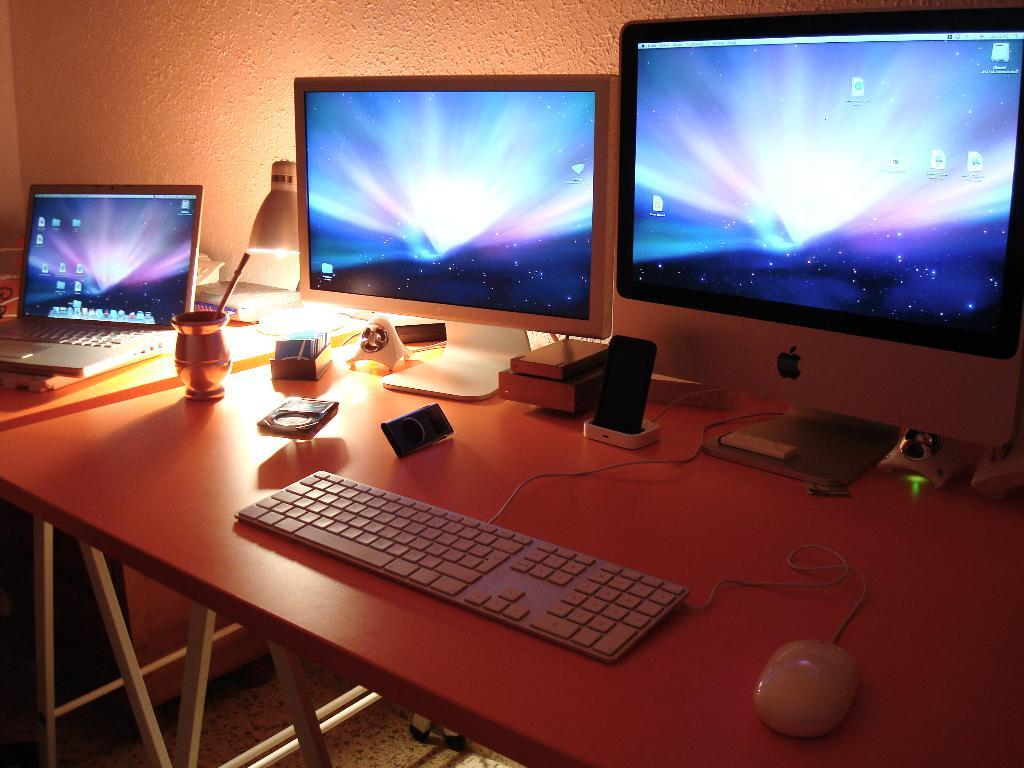What is the main object in the middle of the image? There is a table in the middle of the image. What electronic devices are on the table? A laptop, keyboard, mouse, and monitor are on the table. What other items are on the table? A mobile and a light are on the table. What can be seen in the background of the image? There is a wall in the background of the image. Who is the servant attending to in the image? There is no servant present in the image. What type of hose is connected to the laptop in the image? There is no hose connected to the laptop or any other item in the image. 